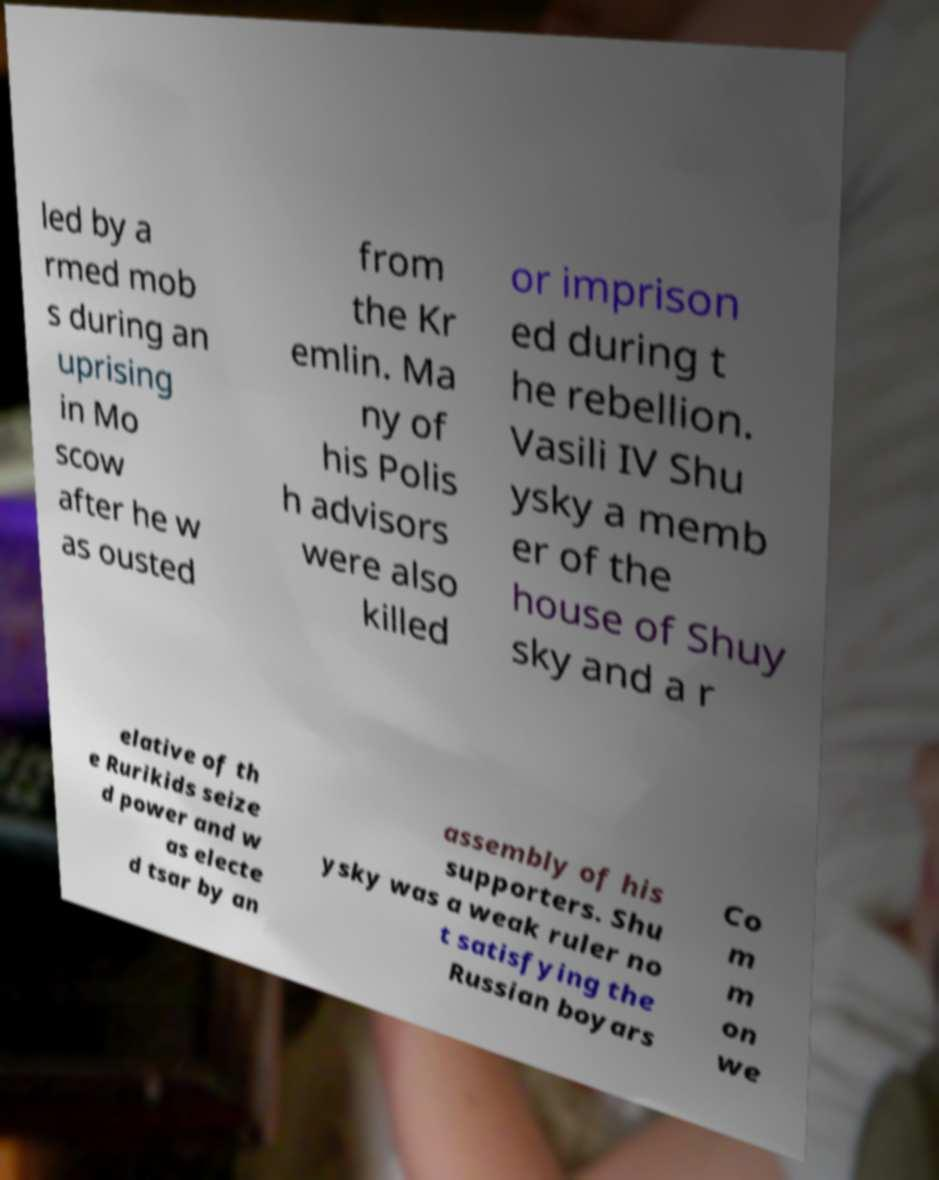What messages or text are displayed in this image? I need them in a readable, typed format. led by a rmed mob s during an uprising in Mo scow after he w as ousted from the Kr emlin. Ma ny of his Polis h advisors were also killed or imprison ed during t he rebellion. Vasili IV Shu ysky a memb er of the house of Shuy sky and a r elative of th e Rurikids seize d power and w as electe d tsar by an assembly of his supporters. Shu ysky was a weak ruler no t satisfying the Russian boyars Co m m on we 